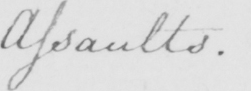Transcribe the text shown in this historical manuscript line. Assaults . 